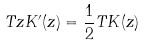Convert formula to latex. <formula><loc_0><loc_0><loc_500><loc_500>T z K ^ { \prime } ( z ) = \frac { 1 } { 2 } T K ( z )</formula> 